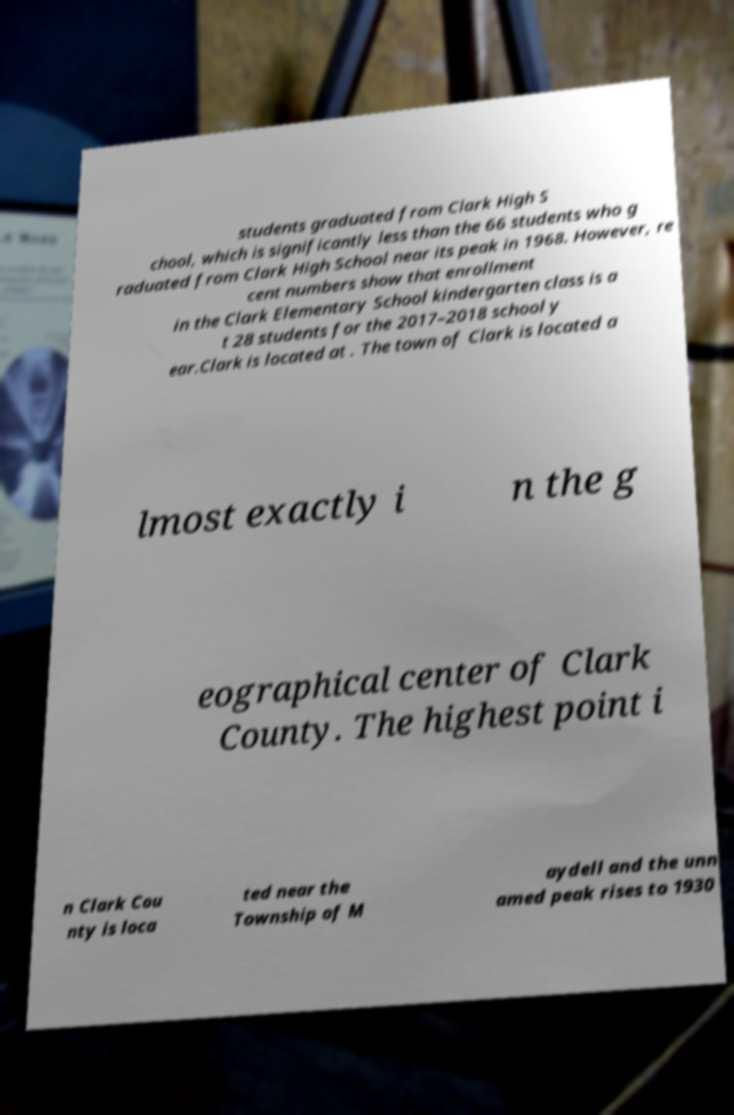Can you read and provide the text displayed in the image?This photo seems to have some interesting text. Can you extract and type it out for me? students graduated from Clark High S chool, which is significantly less than the 66 students who g raduated from Clark High School near its peak in 1968. However, re cent numbers show that enrollment in the Clark Elementary School kindergarten class is a t 28 students for the 2017–2018 school y ear.Clark is located at . The town of Clark is located a lmost exactly i n the g eographical center of Clark County. The highest point i n Clark Cou nty is loca ted near the Township of M aydell and the unn amed peak rises to 1930 